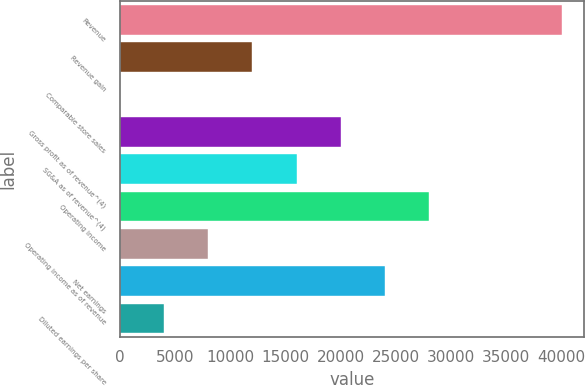Convert chart. <chart><loc_0><loc_0><loc_500><loc_500><bar_chart><fcel>Revenue<fcel>Revenue gain<fcel>Comparable store sales<fcel>Gross profit as of revenue^(4)<fcel>SG&A as of revenue^(4)<fcel>Operating income<fcel>Operating income as of revenue<fcel>Net earnings<fcel>Diluted earnings per share<nl><fcel>40023<fcel>12008.9<fcel>2.9<fcel>20013<fcel>16010.9<fcel>28017<fcel>8006.92<fcel>24015<fcel>4004.91<nl></chart> 